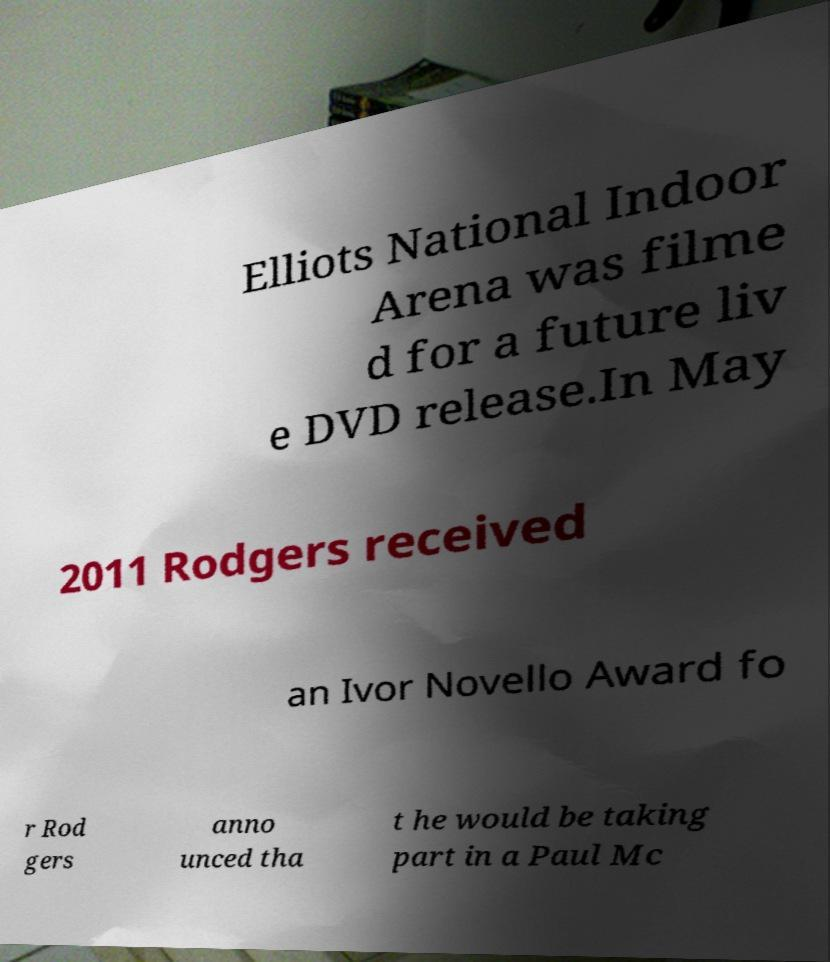Please read and relay the text visible in this image. What does it say? Elliots National Indoor Arena was filme d for a future liv e DVD release.In May 2011 Rodgers received an Ivor Novello Award fo r Rod gers anno unced tha t he would be taking part in a Paul Mc 